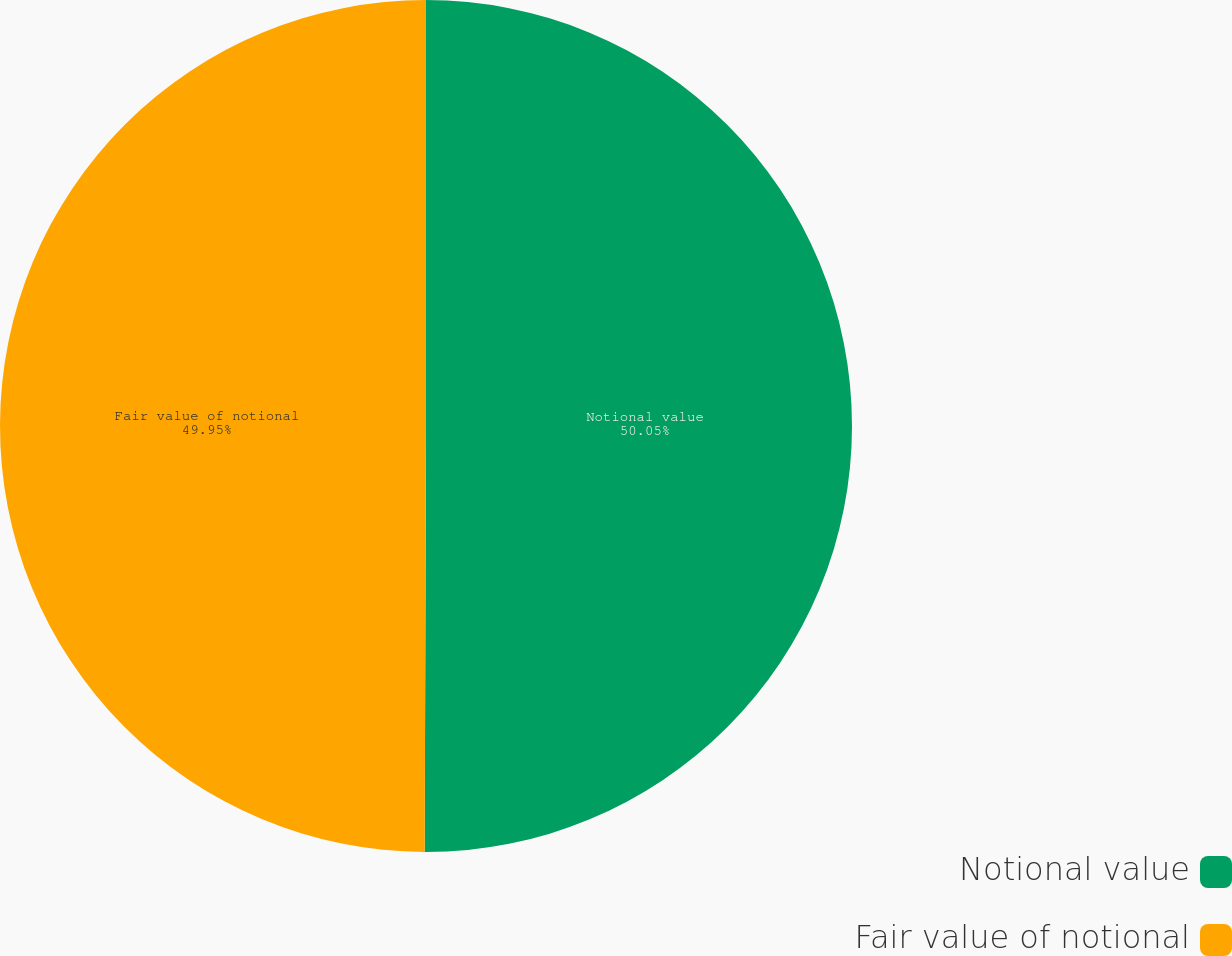Convert chart to OTSL. <chart><loc_0><loc_0><loc_500><loc_500><pie_chart><fcel>Notional value<fcel>Fair value of notional<nl><fcel>50.05%<fcel>49.95%<nl></chart> 